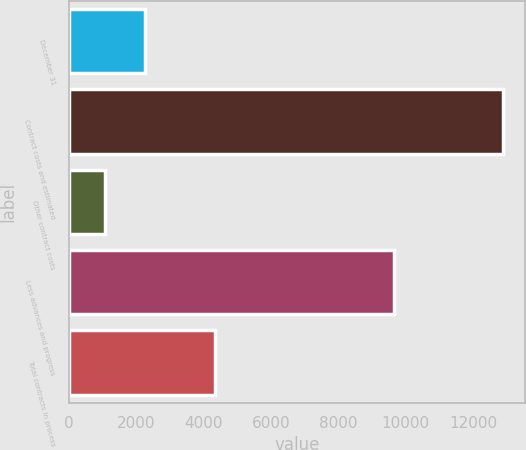<chart> <loc_0><loc_0><loc_500><loc_500><bar_chart><fcel>December 31<fcel>Contract costs and estimated<fcel>Other contract costs<fcel>Less advances and progress<fcel>Total contracts in process<nl><fcel>2260.6<fcel>12904<fcel>1078<fcel>9641<fcel>4341<nl></chart> 